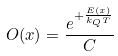Convert formula to latex. <formula><loc_0><loc_0><loc_500><loc_500>O ( x ) = \frac { e ^ { + \frac { E ( x ) } { k _ { Q } T } } } { C }</formula> 